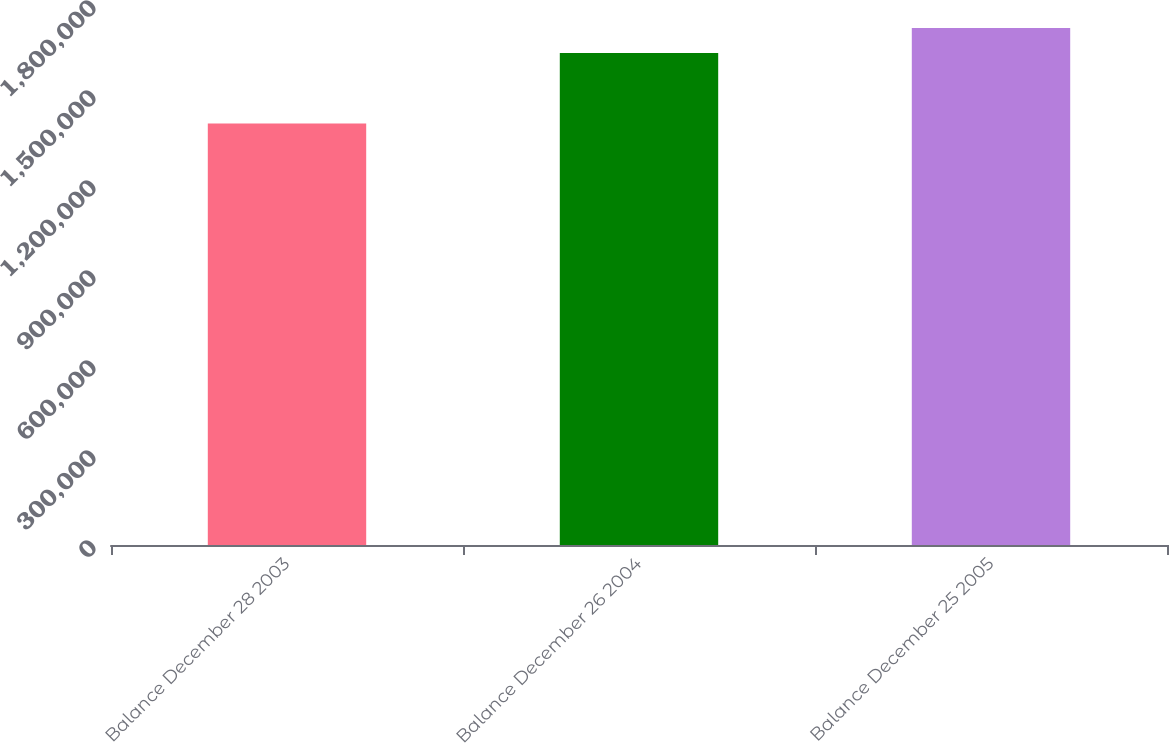Convert chart to OTSL. <chart><loc_0><loc_0><loc_500><loc_500><bar_chart><fcel>Balance December 28 2003<fcel>Balance December 26 2004<fcel>Balance December 25 2005<nl><fcel>1.40524e+06<fcel>1.63972e+06<fcel>1.72348e+06<nl></chart> 